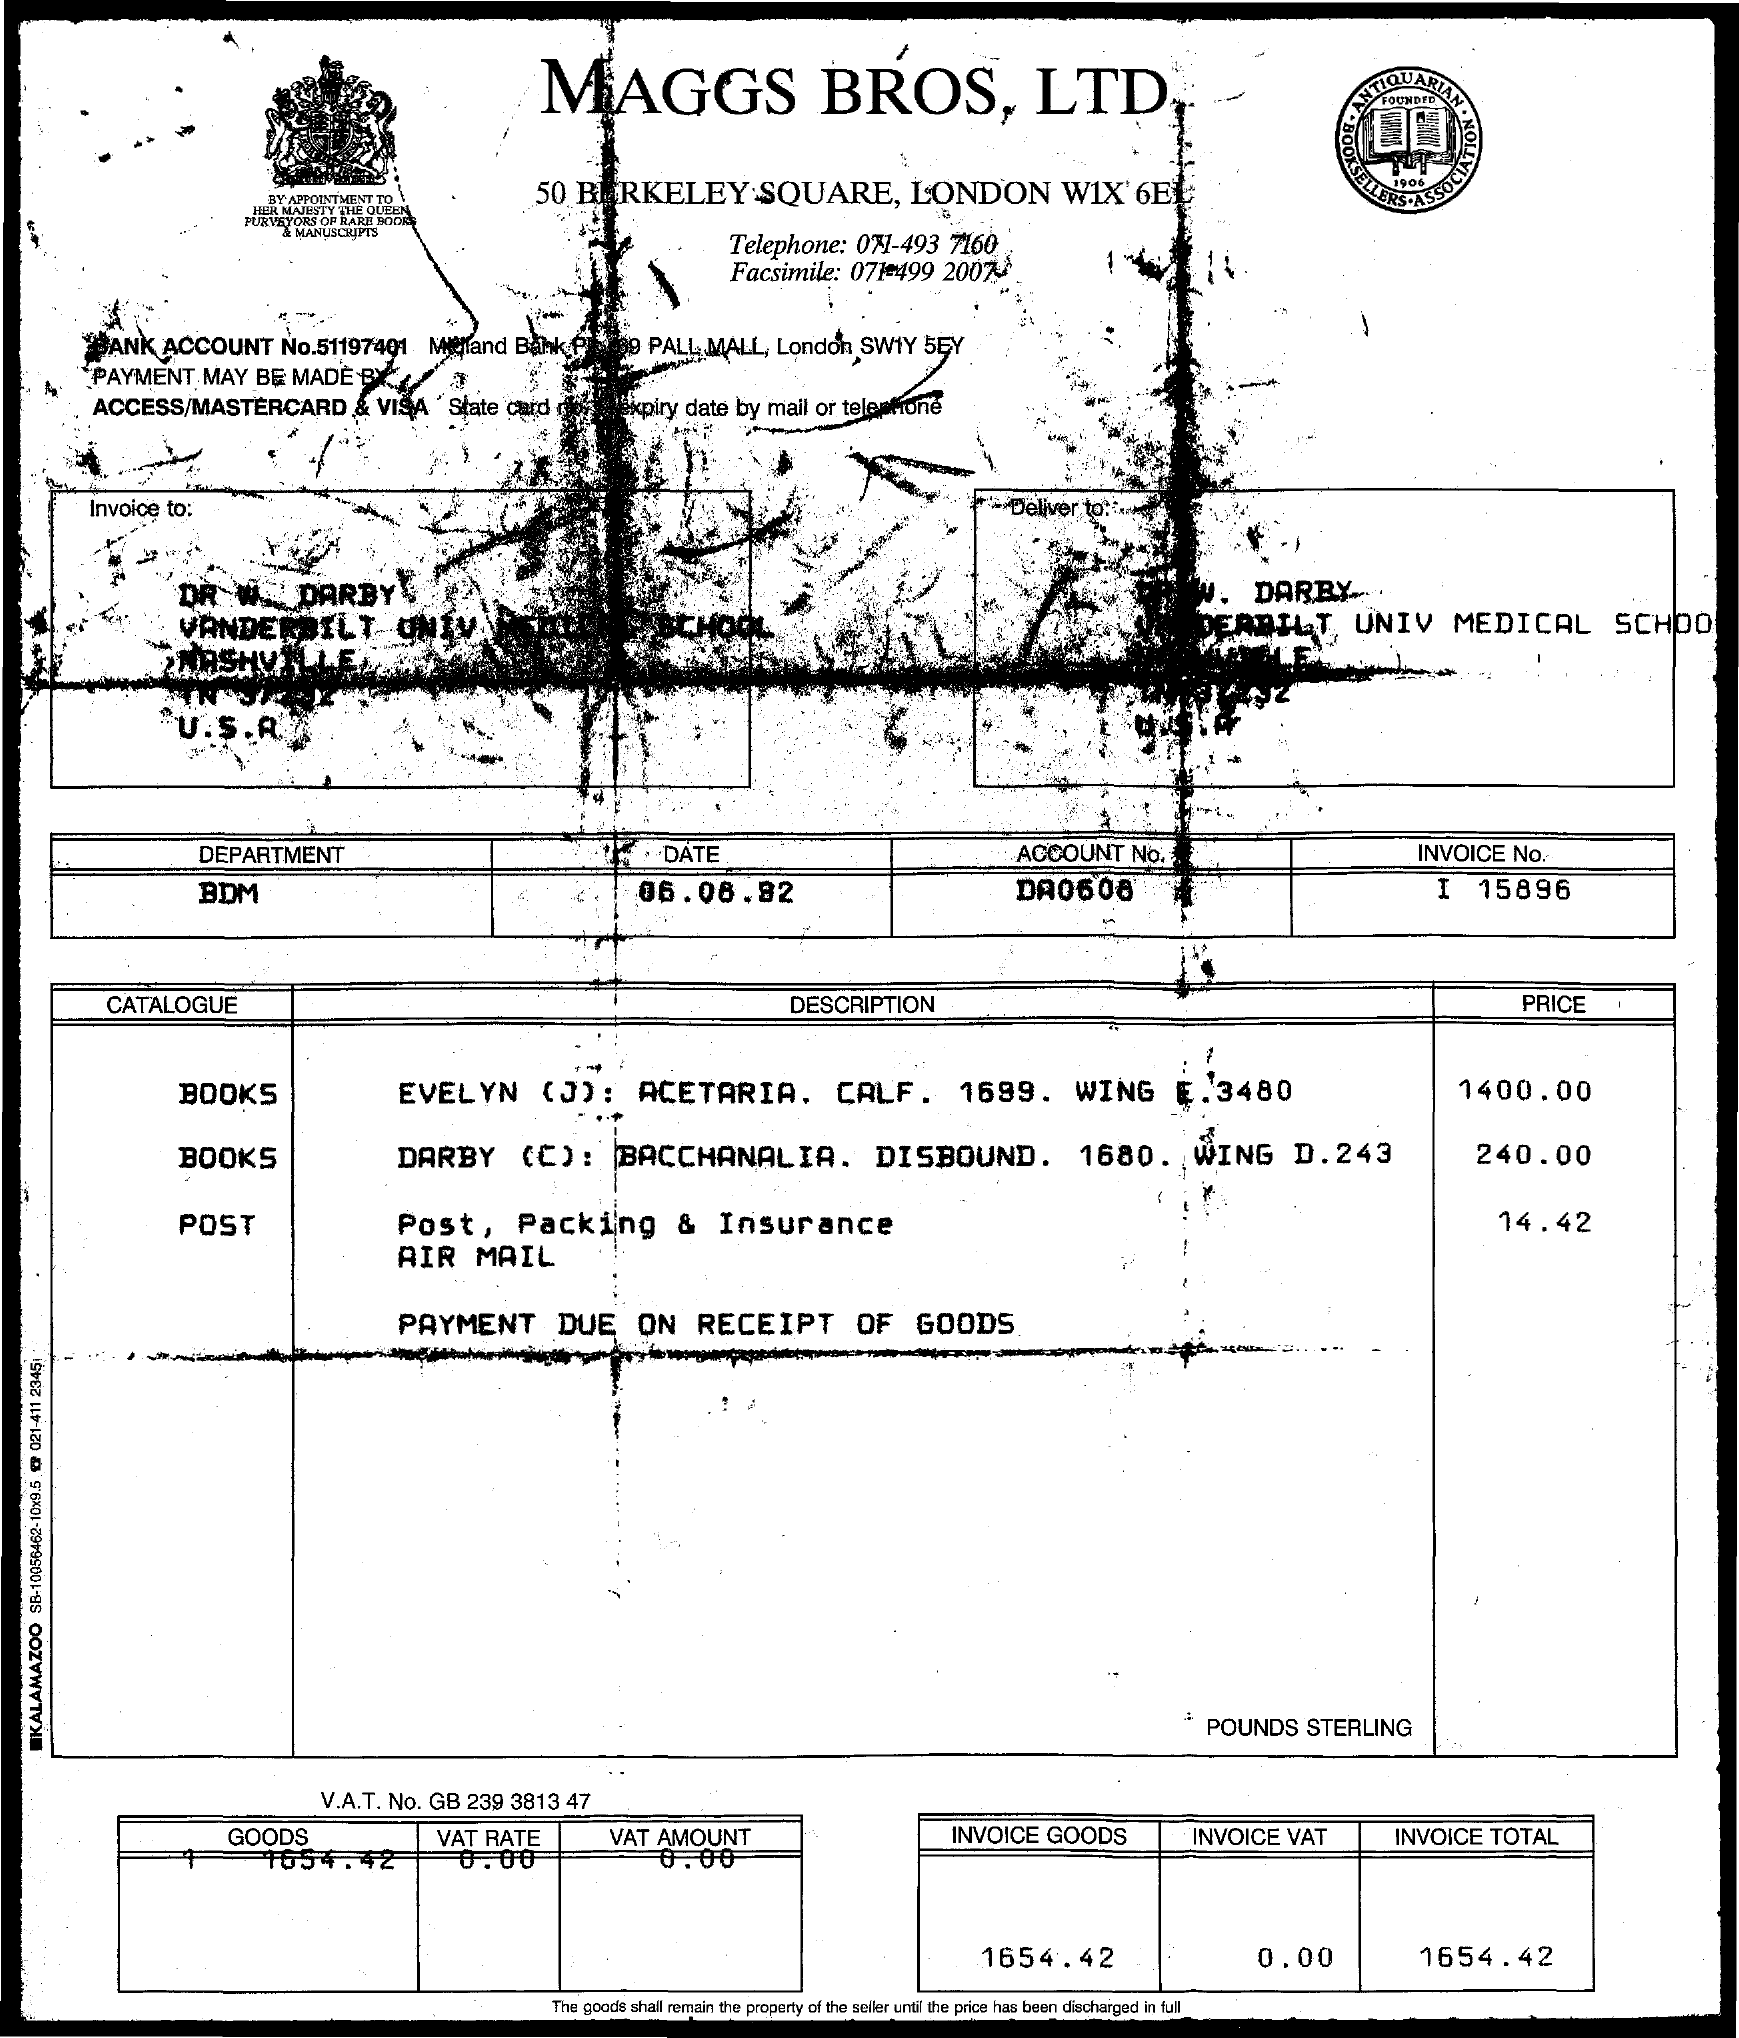Identify some key points in this picture. The telephone number is 071-493 7160. The account number is DA0608... The document's title is Maggs Bros. Ltd. The Department Name is what it is. The V.A.T. number is GB 239 3813 47.. 